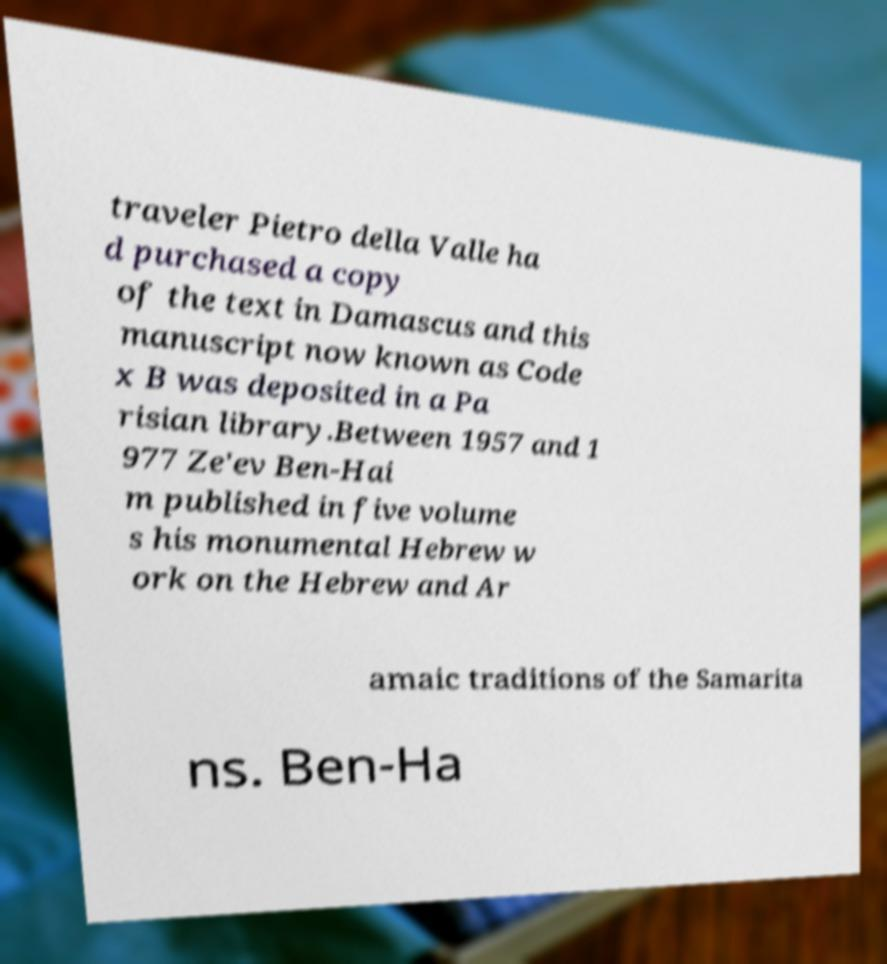There's text embedded in this image that I need extracted. Can you transcribe it verbatim? traveler Pietro della Valle ha d purchased a copy of the text in Damascus and this manuscript now known as Code x B was deposited in a Pa risian library.Between 1957 and 1 977 Ze'ev Ben-Hai m published in five volume s his monumental Hebrew w ork on the Hebrew and Ar amaic traditions of the Samarita ns. Ben-Ha 